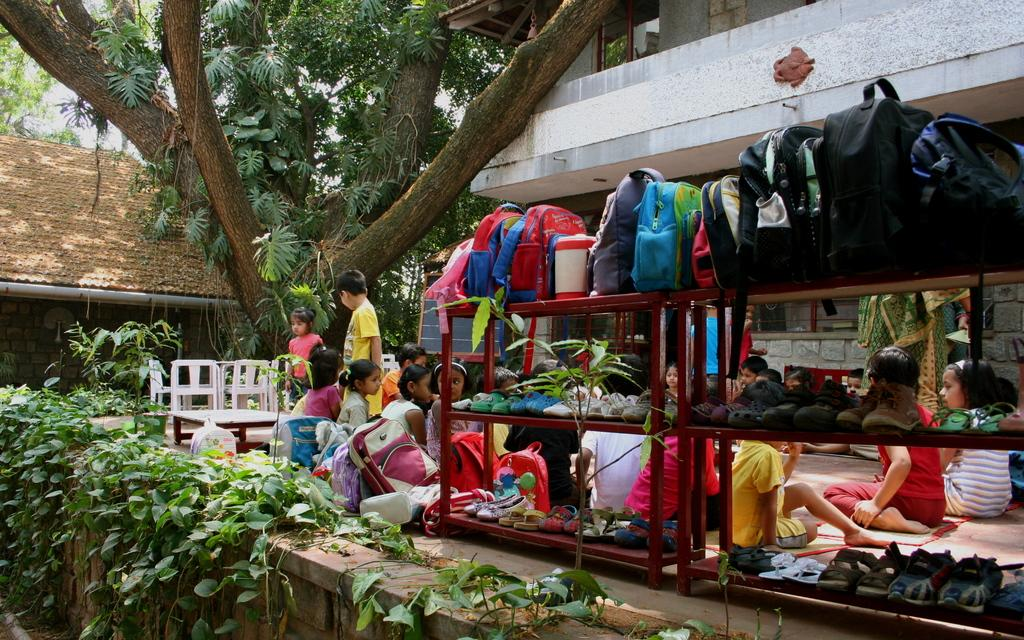What type of items can be seen in the racks in the image? There are footwear's in the racks in the image. What is located above the racks? There are bags above the racks in the image. Can you describe the people in the image? There are children in the image. What type of furniture is present in the image? There are chairs in the image. What kind of decorative element is visible in the image? There is a planter in the image. Besides the bags in the racks, what other bags can be seen in the image? There are bags visible in the image. What type of structures are present in the image? There is a building and a house in the image. What architectural feature is present in the image? There is a window in the image. What type of natural elements are visible in the image? Trees are visible in the image. What adjustment does the caption need to make the image more appealing? There is no caption present in the image, so no adjustment is needed. How many times does the number five appear in the image? The number five is not mentioned or depicted in the image. 